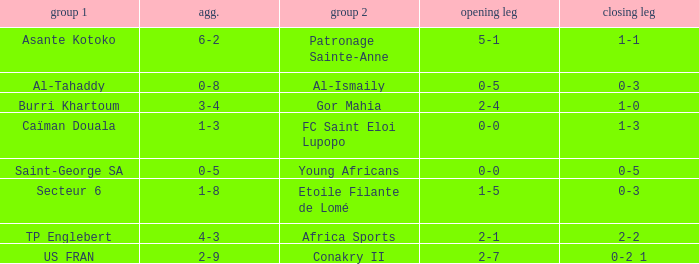Which team lost 0-3 and 0-5? Al-Tahaddy. 